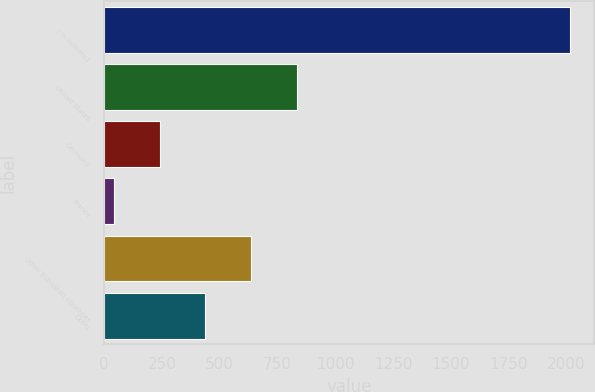<chart> <loc_0><loc_0><loc_500><loc_500><bar_chart><fcel>( in millions)<fcel>United States<fcel>Germany<fcel>France<fcel>Other European countries<fcel>Other<nl><fcel>2017<fcel>832.66<fcel>240.49<fcel>43.1<fcel>635.27<fcel>437.88<nl></chart> 